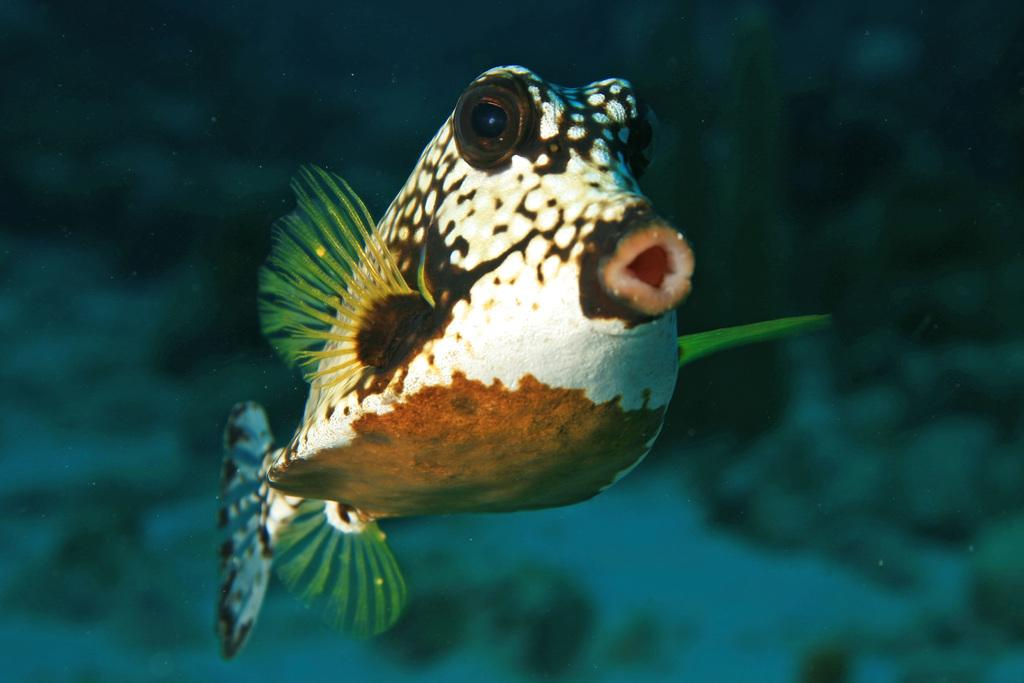What is the main subject of the image? There is a fish in the center of the image. What type of thunder can be heard in the image? There is no thunder present in the image, as it features a fish in the center. What color is the underwear worn by the fish in the image? There is no underwear present in the image, as it features a fish in the center. 